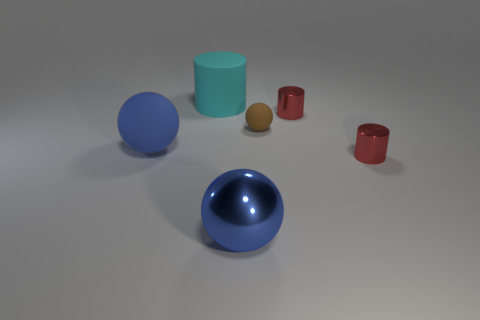Add 2 shiny things. How many objects exist? 8 Subtract all blue spheres. How many spheres are left? 1 Subtract all red shiny cylinders. How many cylinders are left? 1 Subtract 0 green cylinders. How many objects are left? 6 Subtract 2 spheres. How many spheres are left? 1 Subtract all gray spheres. Subtract all brown cubes. How many spheres are left? 3 Subtract all red cylinders. How many blue balls are left? 2 Subtract all small gray spheres. Subtract all tiny brown spheres. How many objects are left? 5 Add 6 small red things. How many small red things are left? 8 Add 2 large matte cylinders. How many large matte cylinders exist? 3 